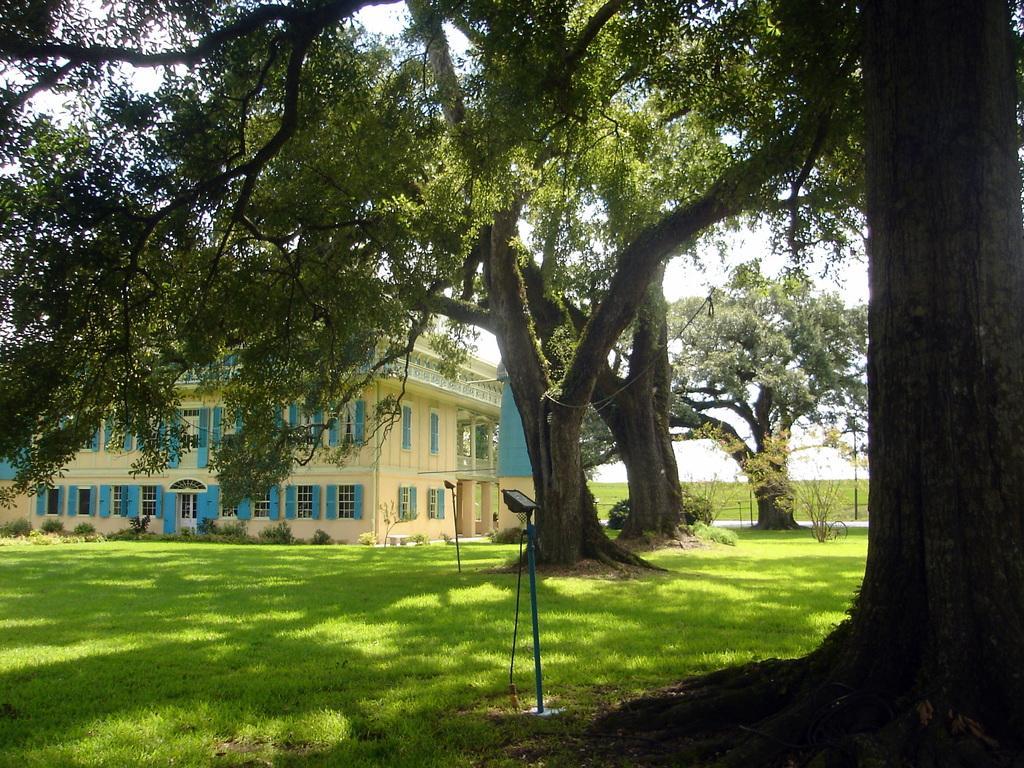Please provide a concise description of this image. In this picture there is a building. On the bottom you can see grass and lights. In the background we can see farmland and trees. Here it's a sky. On the left we can see plants near to the windows. 